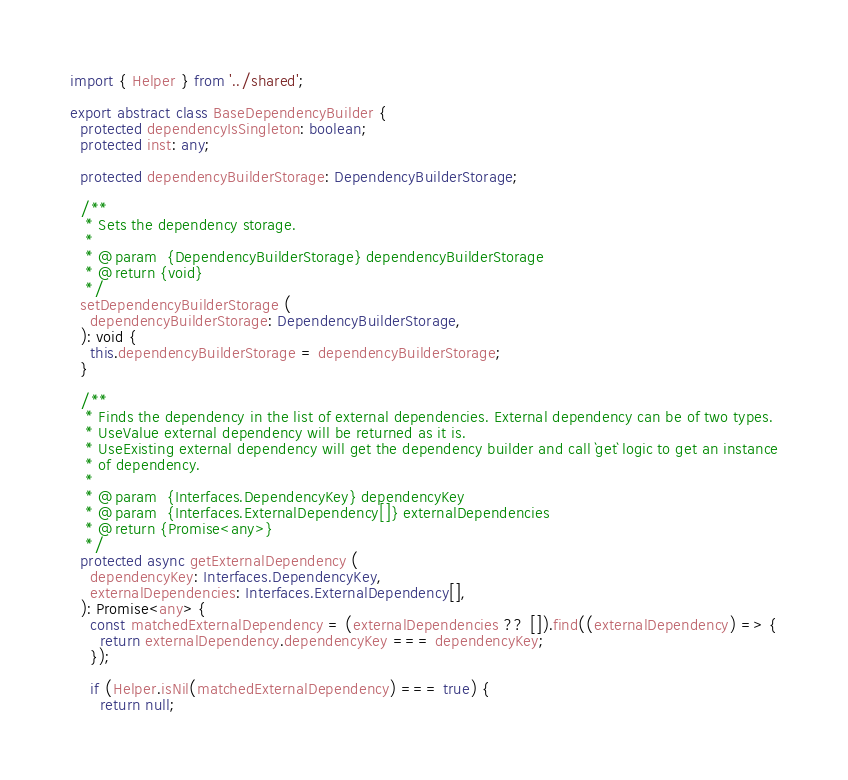Convert code to text. <code><loc_0><loc_0><loc_500><loc_500><_TypeScript_>import { Helper } from '../shared';

export abstract class BaseDependencyBuilder {
  protected dependencyIsSingleton: boolean;
  protected inst: any;

  protected dependencyBuilderStorage: DependencyBuilderStorage;

  /**
   * Sets the dependency storage.
   *
   * @param  {DependencyBuilderStorage} dependencyBuilderStorage
   * @return {void}
   */
  setDependencyBuilderStorage (
    dependencyBuilderStorage: DependencyBuilderStorage,
  ): void {
    this.dependencyBuilderStorage = dependencyBuilderStorage;
  }

  /**
   * Finds the dependency in the list of external dependencies. External dependency can be of two types.
   * UseValue external dependency will be returned as it is.
   * UseExisting external dependency will get the dependency builder and call `get` logic to get an instance
   * of dependency.
   *
   * @param  {Interfaces.DependencyKey} dependencyKey
   * @param  {Interfaces.ExternalDependency[]} externalDependencies
   * @return {Promise<any>}
   */
  protected async getExternalDependency (
    dependencyKey: Interfaces.DependencyKey,
    externalDependencies: Interfaces.ExternalDependency[],
  ): Promise<any> {
    const matchedExternalDependency = (externalDependencies ?? []).find((externalDependency) => {
      return externalDependency.dependencyKey === dependencyKey;
    });

    if (Helper.isNil(matchedExternalDependency) === true) {
      return null;</code> 